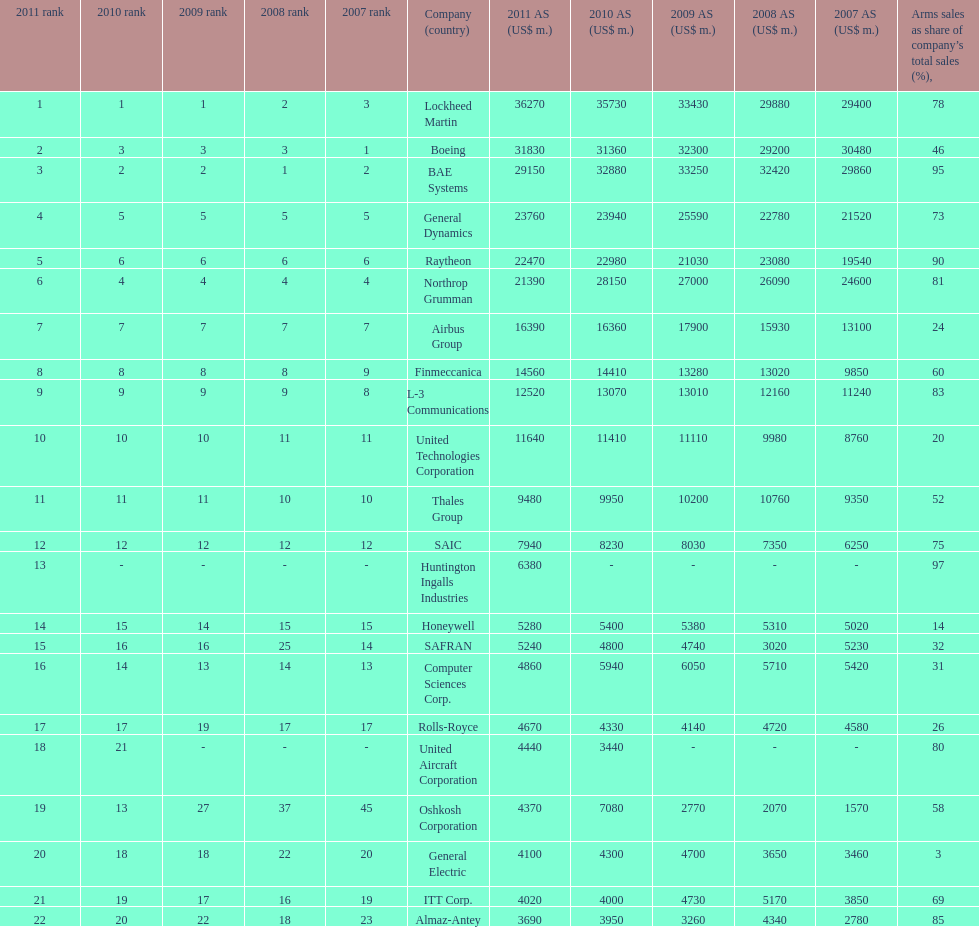Which is the only company to have under 10% arms sales as share of company's total sales? General Electric. 